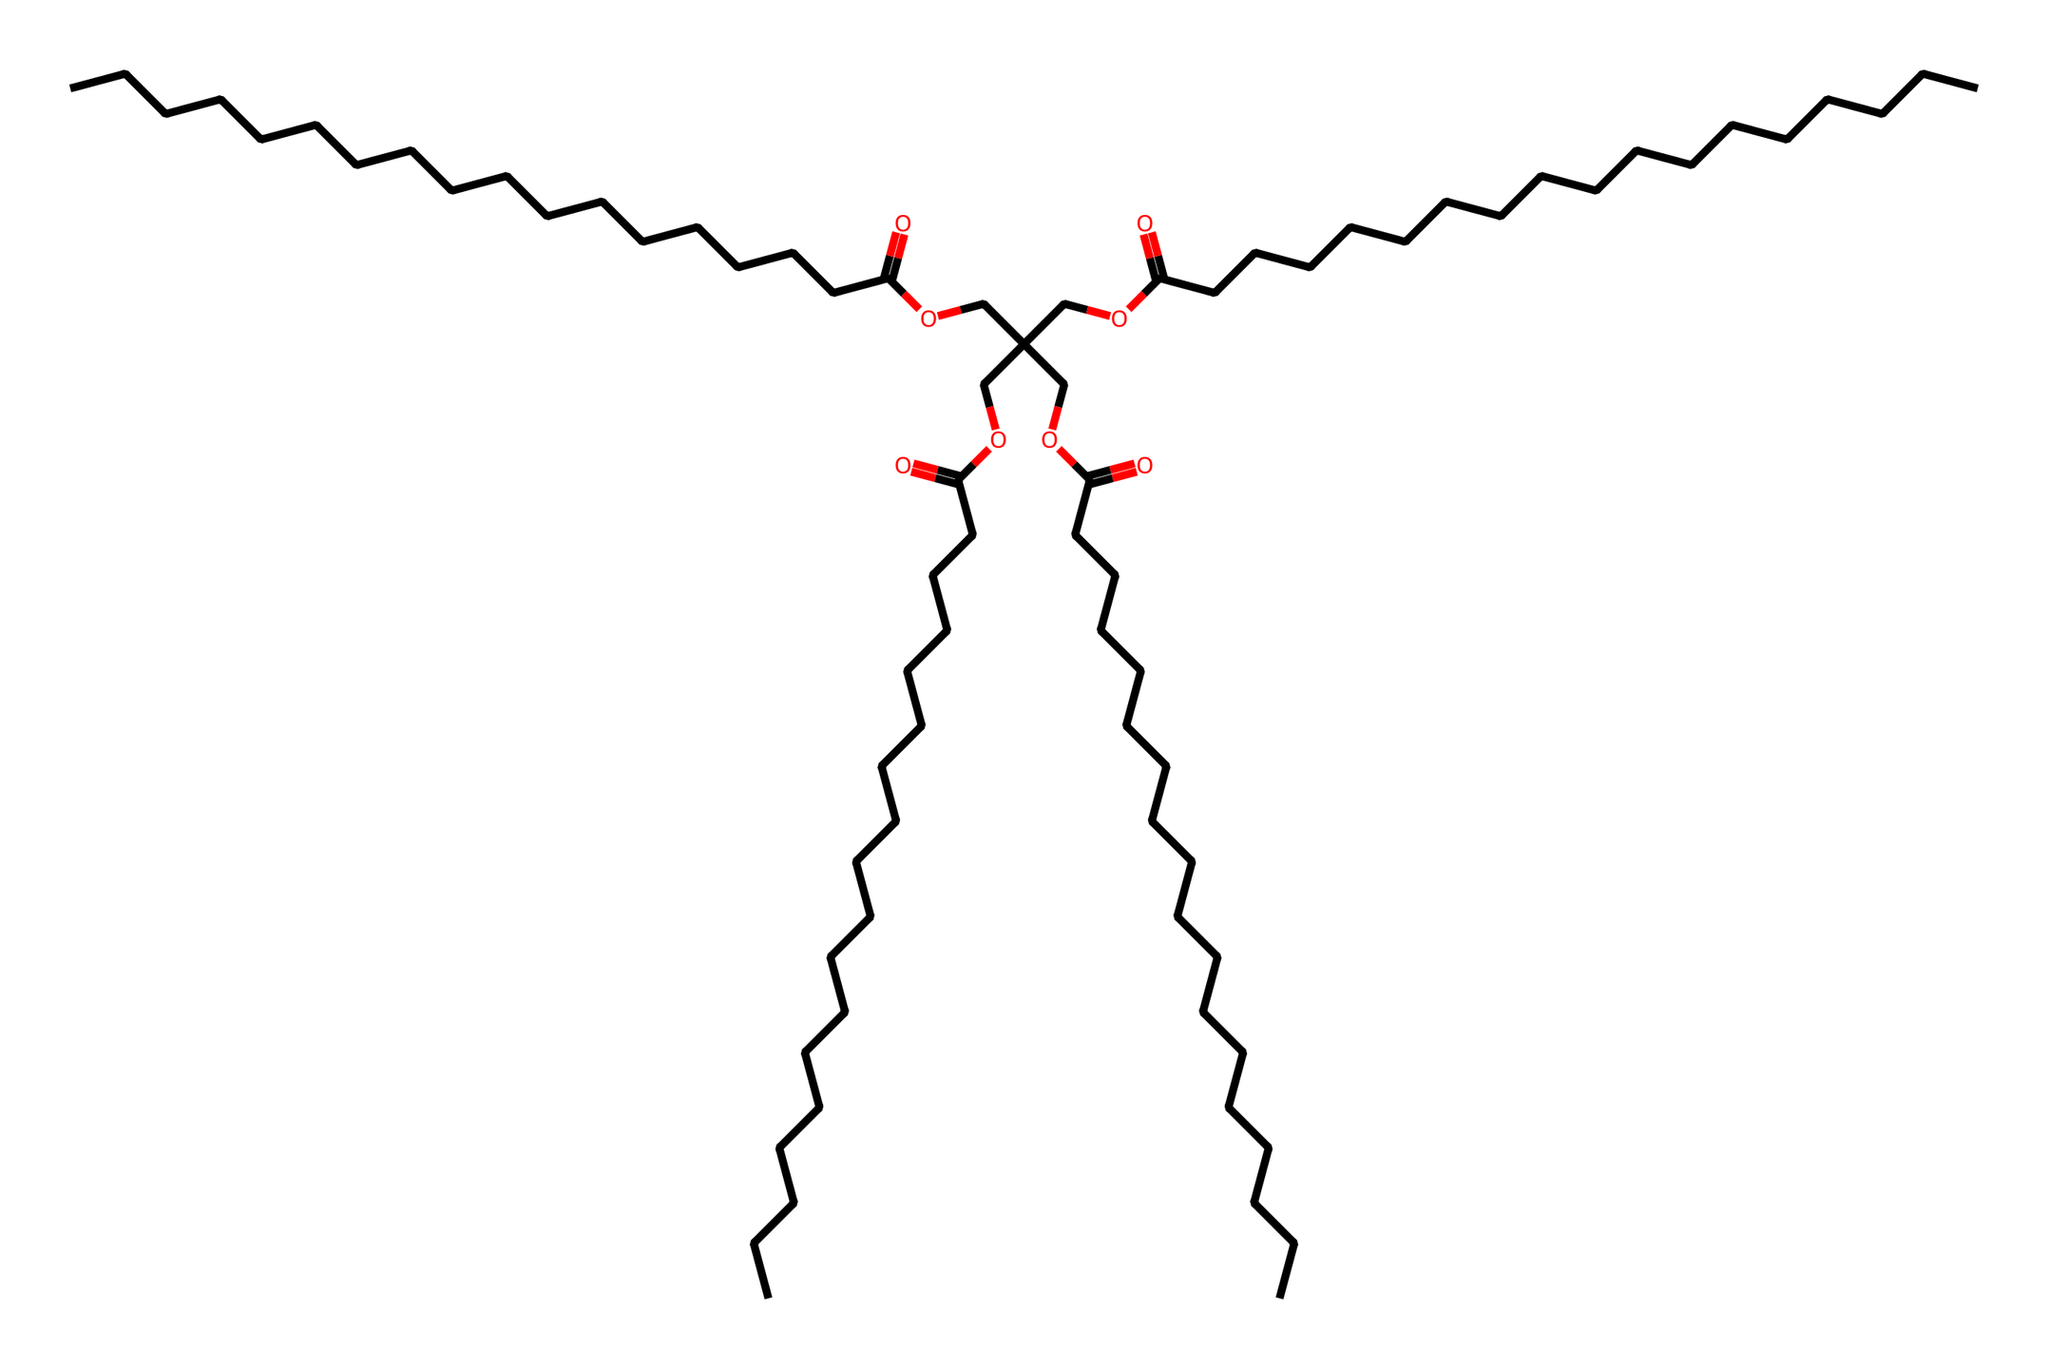What is the main functional group present in this compound? The presence of the —COO— (ester) and —C(=O)O— (carboxylic acid) groups can be identified in the structure. These indicate that the main functional group in the compound is an ester.
Answer: ester How many carbon atoms are in this structure? By counting the number of carbon atoms represented in the SMILES notation, we identify a total of 27 carbon atoms when including all sections of the chain and branching points.
Answer: 27 What type of chemical is this compound classified as? Given that it consists of predominantly carbon and hydrogen atoms with ester bonds and no ions or electrolytic functionalities, this compound is classified as a non-electrolyte, which does not dissociate in solution.
Answer: non-electrolyte How many ester linkages are present in this structure? The chemical structure displays several instances of the —COO— ether linkages. By examining the functional groups, we find a total of four distinct ester linkages corresponding to four major branches.
Answer: 4 What is the degree of saturation (number of double bonds) in this compound? Each carbon atom in the longest chain is accounted, and there are double bonds shown in the —C(=O)— parts, indicating the presence of carbonyl functionalities, but the overall structure remains saturated with no double bonds among the main hydrocarbons. Therefore, the degree of saturation is zero.
Answer: 0 Which part of the molecule serves as the primary hydrophobic tail? The long aliphatic carbon chain can be observed at the beginning of the SMILES, indicating the hydrophobic character of the compound, which allows it to provide good lubrication for engines. The long hydrocarbon chain is responsible for this property.
Answer: long carbon chain 